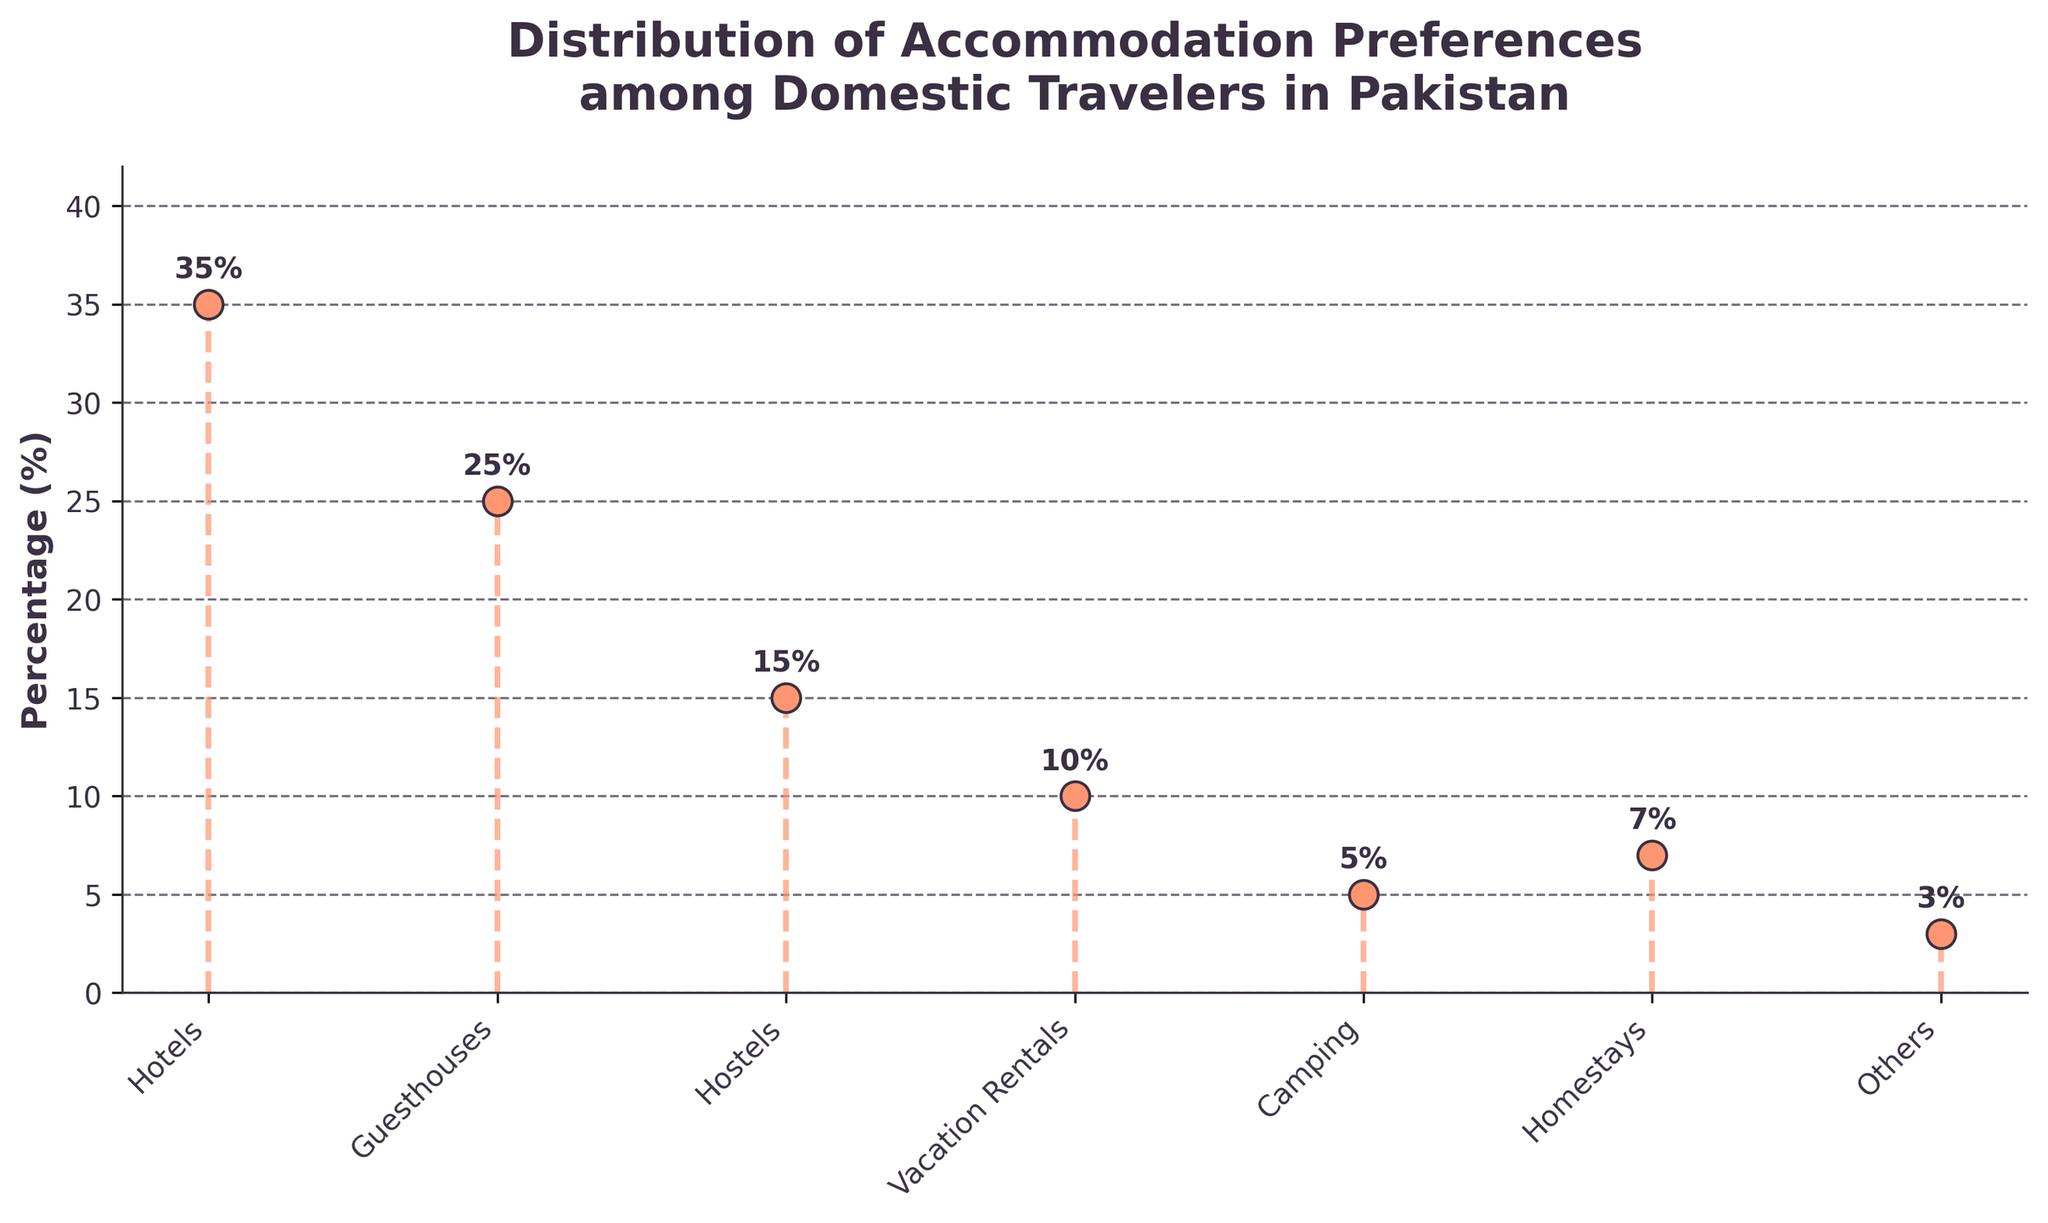What is the title of the figure? The title is usually found at the top of the figure. It provides a brief description of what the plot represents. Here, it reads "Distribution of Accommodation Preferences among Domestic Travelers in Pakistan."
Answer: Distribution of Accommodation Preferences among Domestic Travelers in Pakistan How many categories of accommodation are represented in the plot? By counting the number of unique labels on the x-axis, we can determine the number of accommodation categories shown in the plot.
Answer: 7 Which accommodation type has the highest preference percentage? The tallest stem line in the figure indicates the accommodation type with the highest percentage. The label at the base of this stem line gives the type.
Answer: Hotels What is the percentage difference between hotels and guesthouses? First, identify the percentages for hotels and guesthouses from the figure. Then, subtract the percentage of guesthouses from the percentage of hotels: 35% - 25% = 10%.
Answer: 10% What is the percentage for camping? Locate the label 'Camping' on the x-axis and refer to the stem line associated with it. The percentage at the top of the line indicates the value.
Answer: 5% Which accommodation type has the lowest preference percentage? The shortest stem line in the figure indicates the accommodation type with the lowest percentage. The label at the base of this stem line gives the type.
Answer: Others What is the combined percentage of hostels and homestays? Identify the percentages for both hostels and homestays from the figure. Then, sum these two values: 15% + 7% = 22%.
Answer: 22% Are vacation rentals more popular than guesthouses? Compare the stem lines associated with vacation rentals and guesthouses. The taller stem line represents the more popular accommodation type. Vacation rentals have a lower percentage (10%) compared to guesthouses (25%).
Answer: No Which accommodation types have a percentage above 20%? Identify the stem lines that extend above the 20% mark on the y-axis. The labels at the base of these lines are the types: Hotels (35%) and Guesthouses (25%).
Answer: Hotels, Guesthouses Is the percentage for vacation rentals greater than the combined percentage of camping and others? First, find the percentage for vacation rentals (10%). Then, calculate the combined percentage of camping and others: 5% + 3% = 8%. Compare the two values; 10% (vacation rentals) is greater than 8% (camping + others).
Answer: Yes 